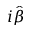<formula> <loc_0><loc_0><loc_500><loc_500>i \hat { \beta }</formula> 